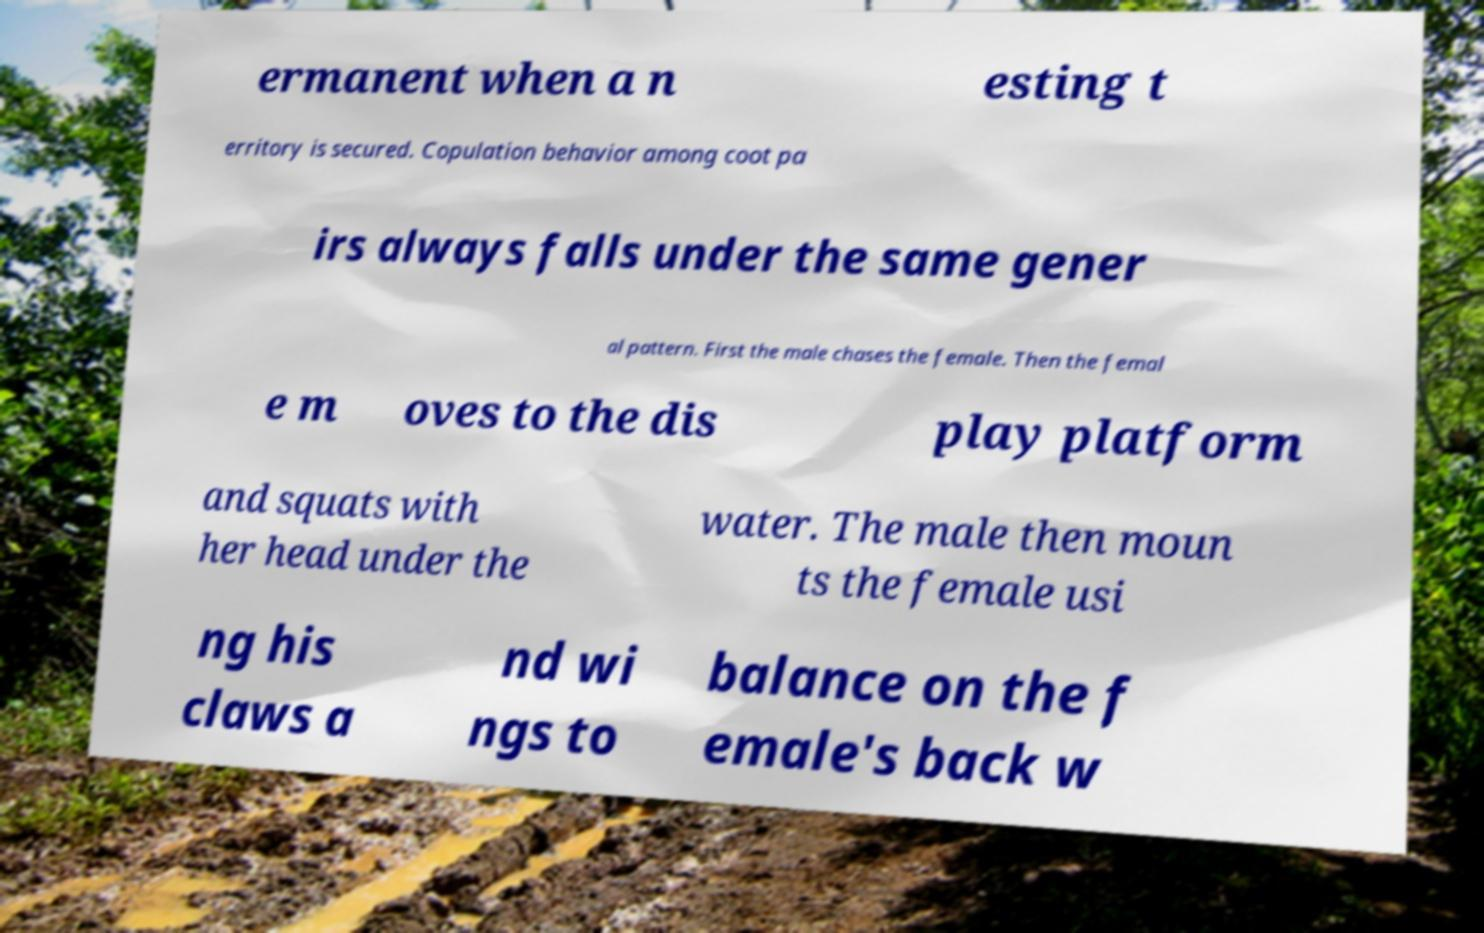For documentation purposes, I need the text within this image transcribed. Could you provide that? ermanent when a n esting t erritory is secured. Copulation behavior among coot pa irs always falls under the same gener al pattern. First the male chases the female. Then the femal e m oves to the dis play platform and squats with her head under the water. The male then moun ts the female usi ng his claws a nd wi ngs to balance on the f emale's back w 